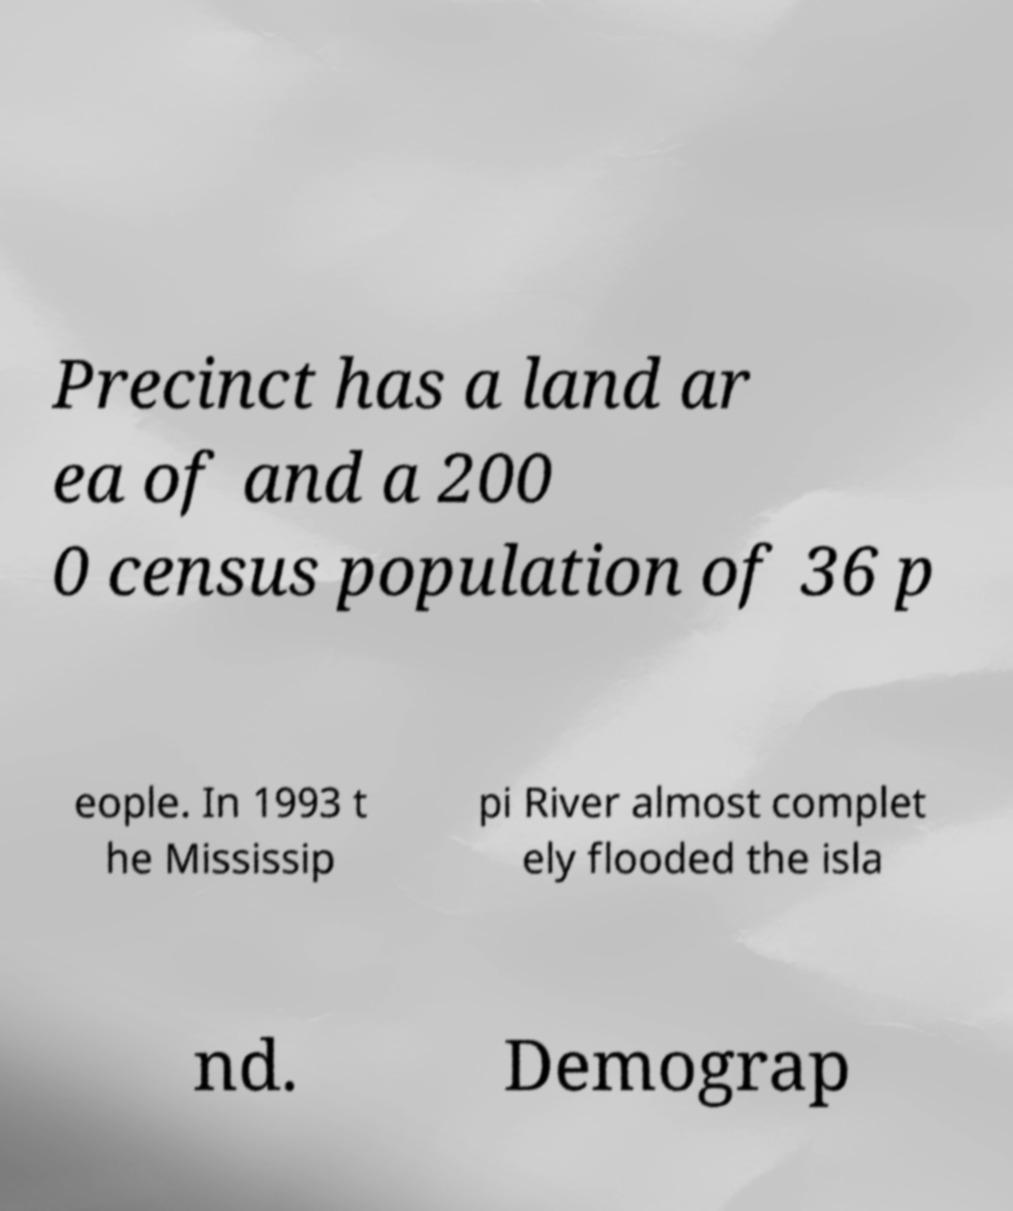Can you accurately transcribe the text from the provided image for me? Precinct has a land ar ea of and a 200 0 census population of 36 p eople. In 1993 t he Mississip pi River almost complet ely flooded the isla nd. Demograp 